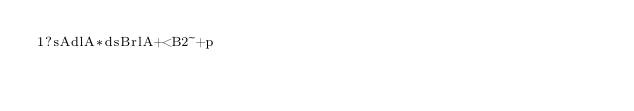Convert code to text. <code><loc_0><loc_0><loc_500><loc_500><_dc_>1?sAdlA*dsBrlA+<B2~+p</code> 